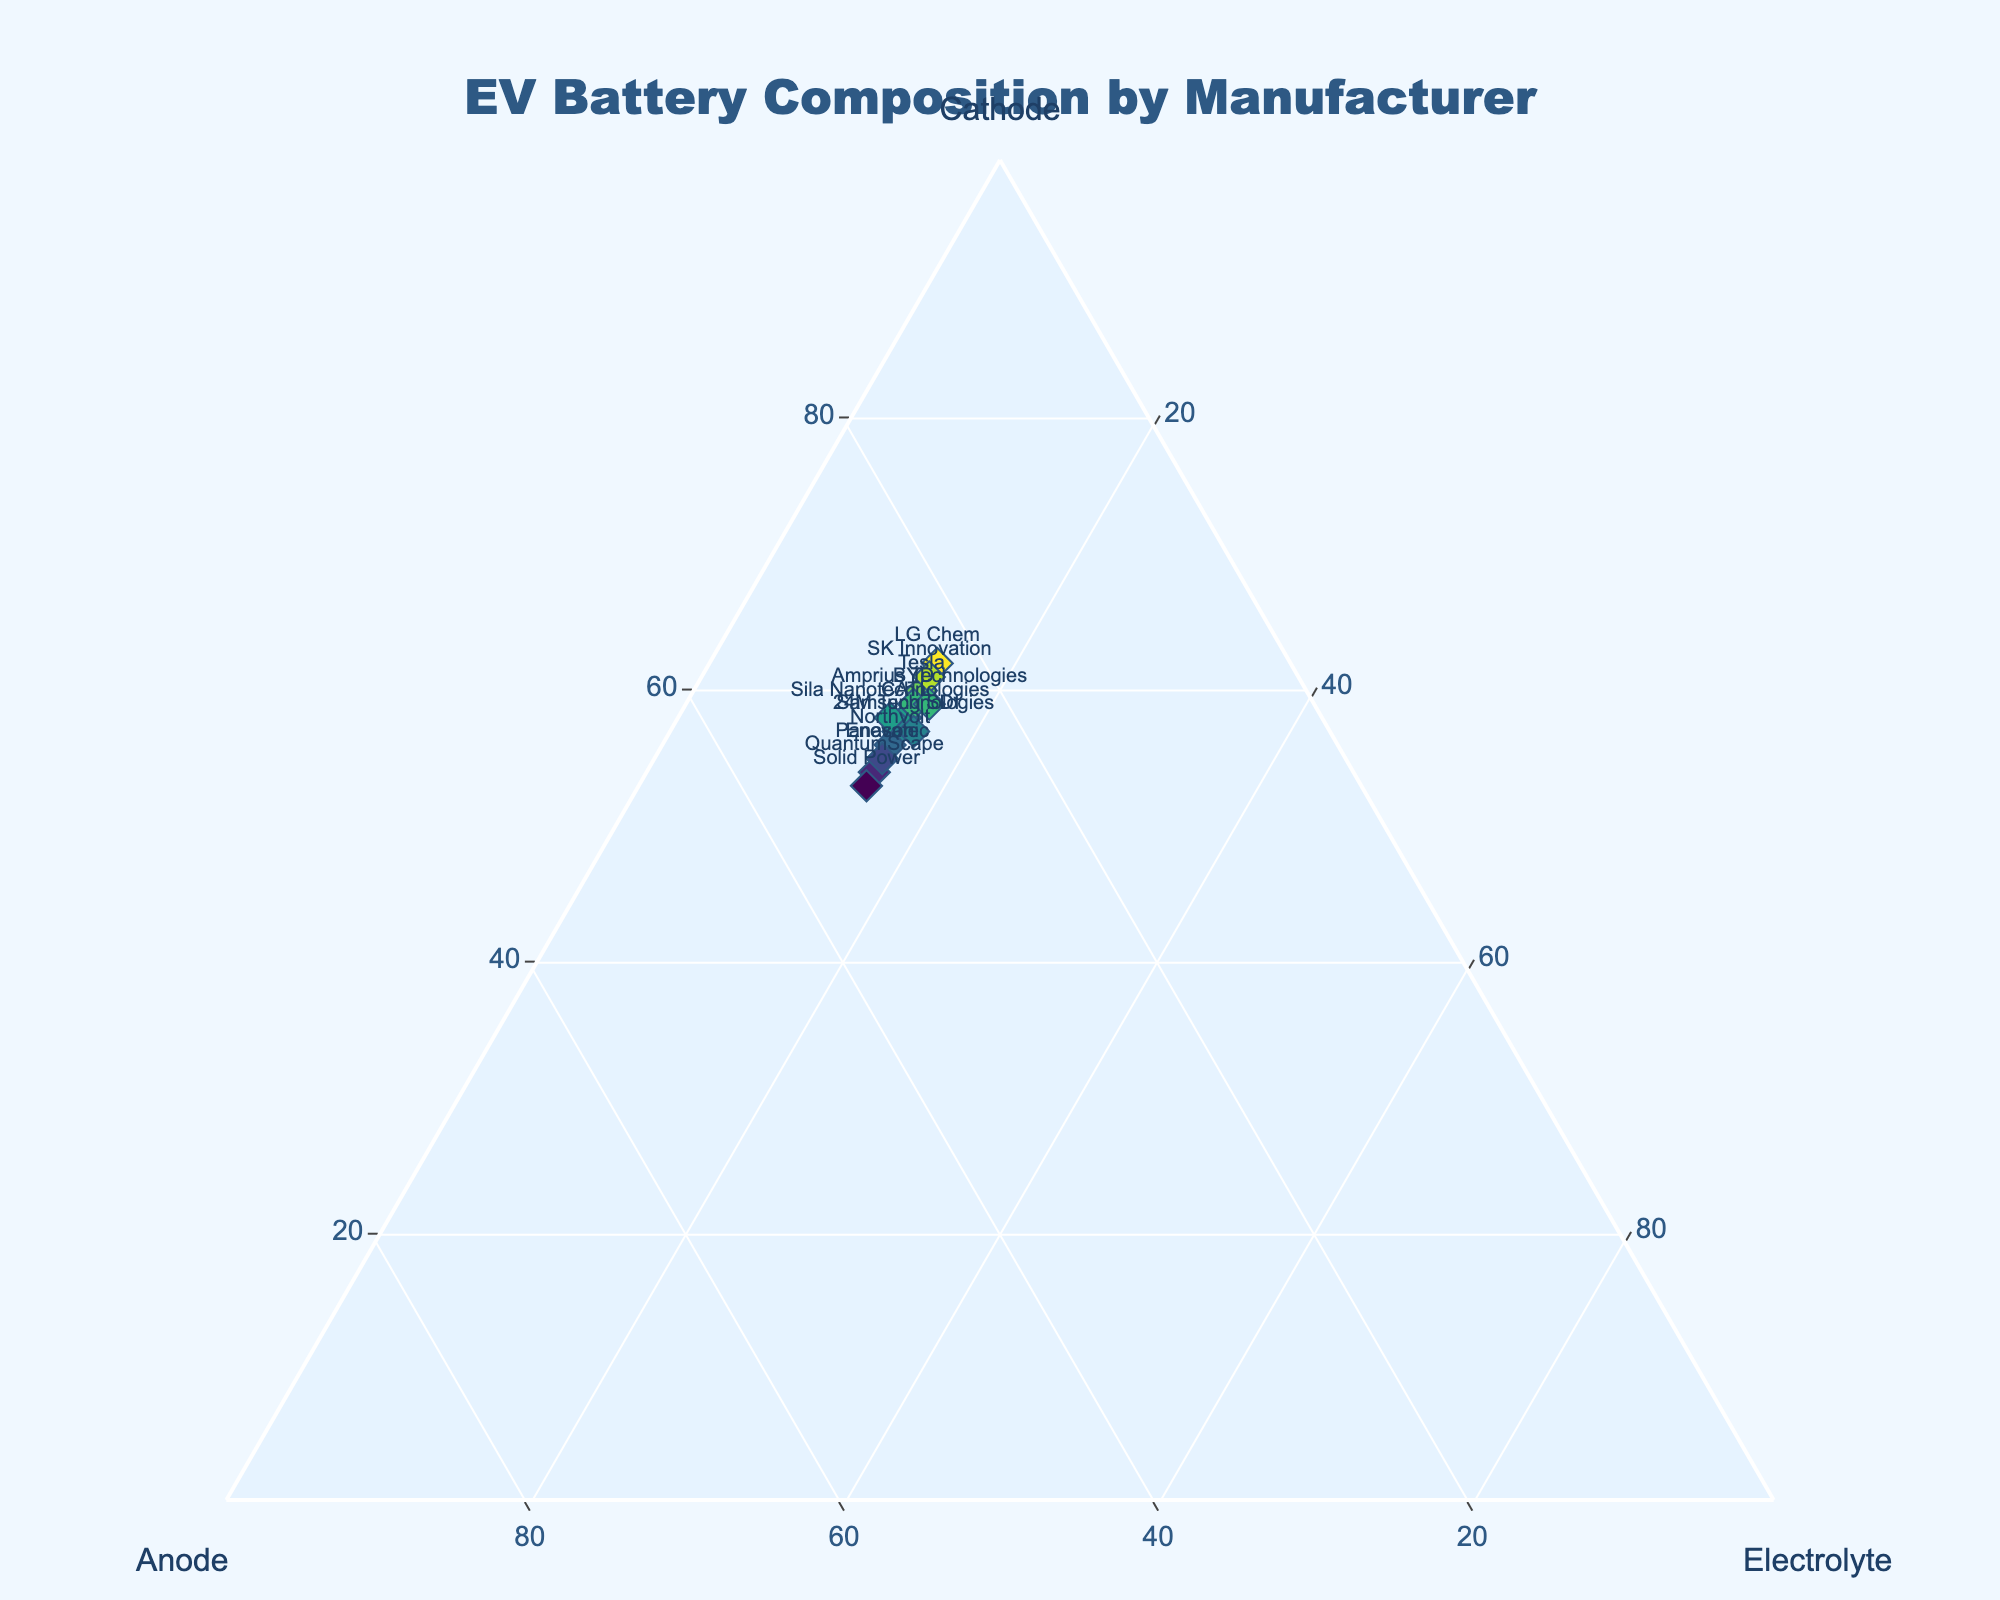What is the title of the figure? The title is usually displayed prominently at the top of the figure. In this case, it's "EV Battery Composition by Manufacturer".
Answer: EV Battery Composition by Manufacturer Which manufacturer uses the highest percentage of cathode materials? To find this, compare the cathode percentages for all manufacturers. LG Chem has the highest percentage with 62%.
Answer: LG Chem How many manufacturers use an electrolyte composition of 15%? Count the data points where the electrolyte percentage is 15%. There are 10 manufacturers with 15% electrolyte.
Answer: 10 What is the average cathode percentage across all manufacturers? Sum the cathode percentages and divide by the number of manufacturers. (60 + 55 + 58 + 62 + 57 + 59 + 61 + 56 + 54 + 53 + 58 + 57 + 59 + 55)/14 = 57.21
Answer: 57.21 Which manufacturer has the highest percentage of anode materials? Compare the anode percentages for all manufacturers. Solid Power has the highest percentage with 32%.
Answer: Solid Power How many manufacturers have a cathode percentage greater than 60%? Count the data points where the cathode percentage is greater than 60%. Three manufacturers (Tesla, LG Chem, SK Innovation) meet this criterion.
Answer: 3 Which manufacturers have the same electrolyte composition? Look for manufacturers with identical electrolyte percentages. Multiple manufacturers share the same electrolyte percentage of 15%. Examples include Tesla, Panasonic, CATL, LG Chem, Samsung SDI, BYD, SK Innovation, Northvolt, QuantumScape, Enevate.
Answer: Tesla, Panasonic, CATL, LG Chem, Samsung SDI, BYD, SK Innovation, Northvolt, QuantumScape, Enevate What is the sum of cathode and anode percentages for Panasonic? Add the cathode and anode percentages for Panasonic. 55 + 30 = 85
Answer: 85 Which manufacturer has the smallest difference between cathode and anode percentages? Calculate the absolute differences between cathode and anode percentages for each manufacturer and find the smallest difference. By comparing these, Enevate has the smallest difference of 25 (55 - 30).
Answer: Enevate Is there any manufacturer with an exactly balanced composition of cathode, anode, and electrolyte? Check if any manufacturer has equal percentages for cathode, anode, and electrolyte. None of the manufacturers have equal percentages across all three components.
Answer: No 